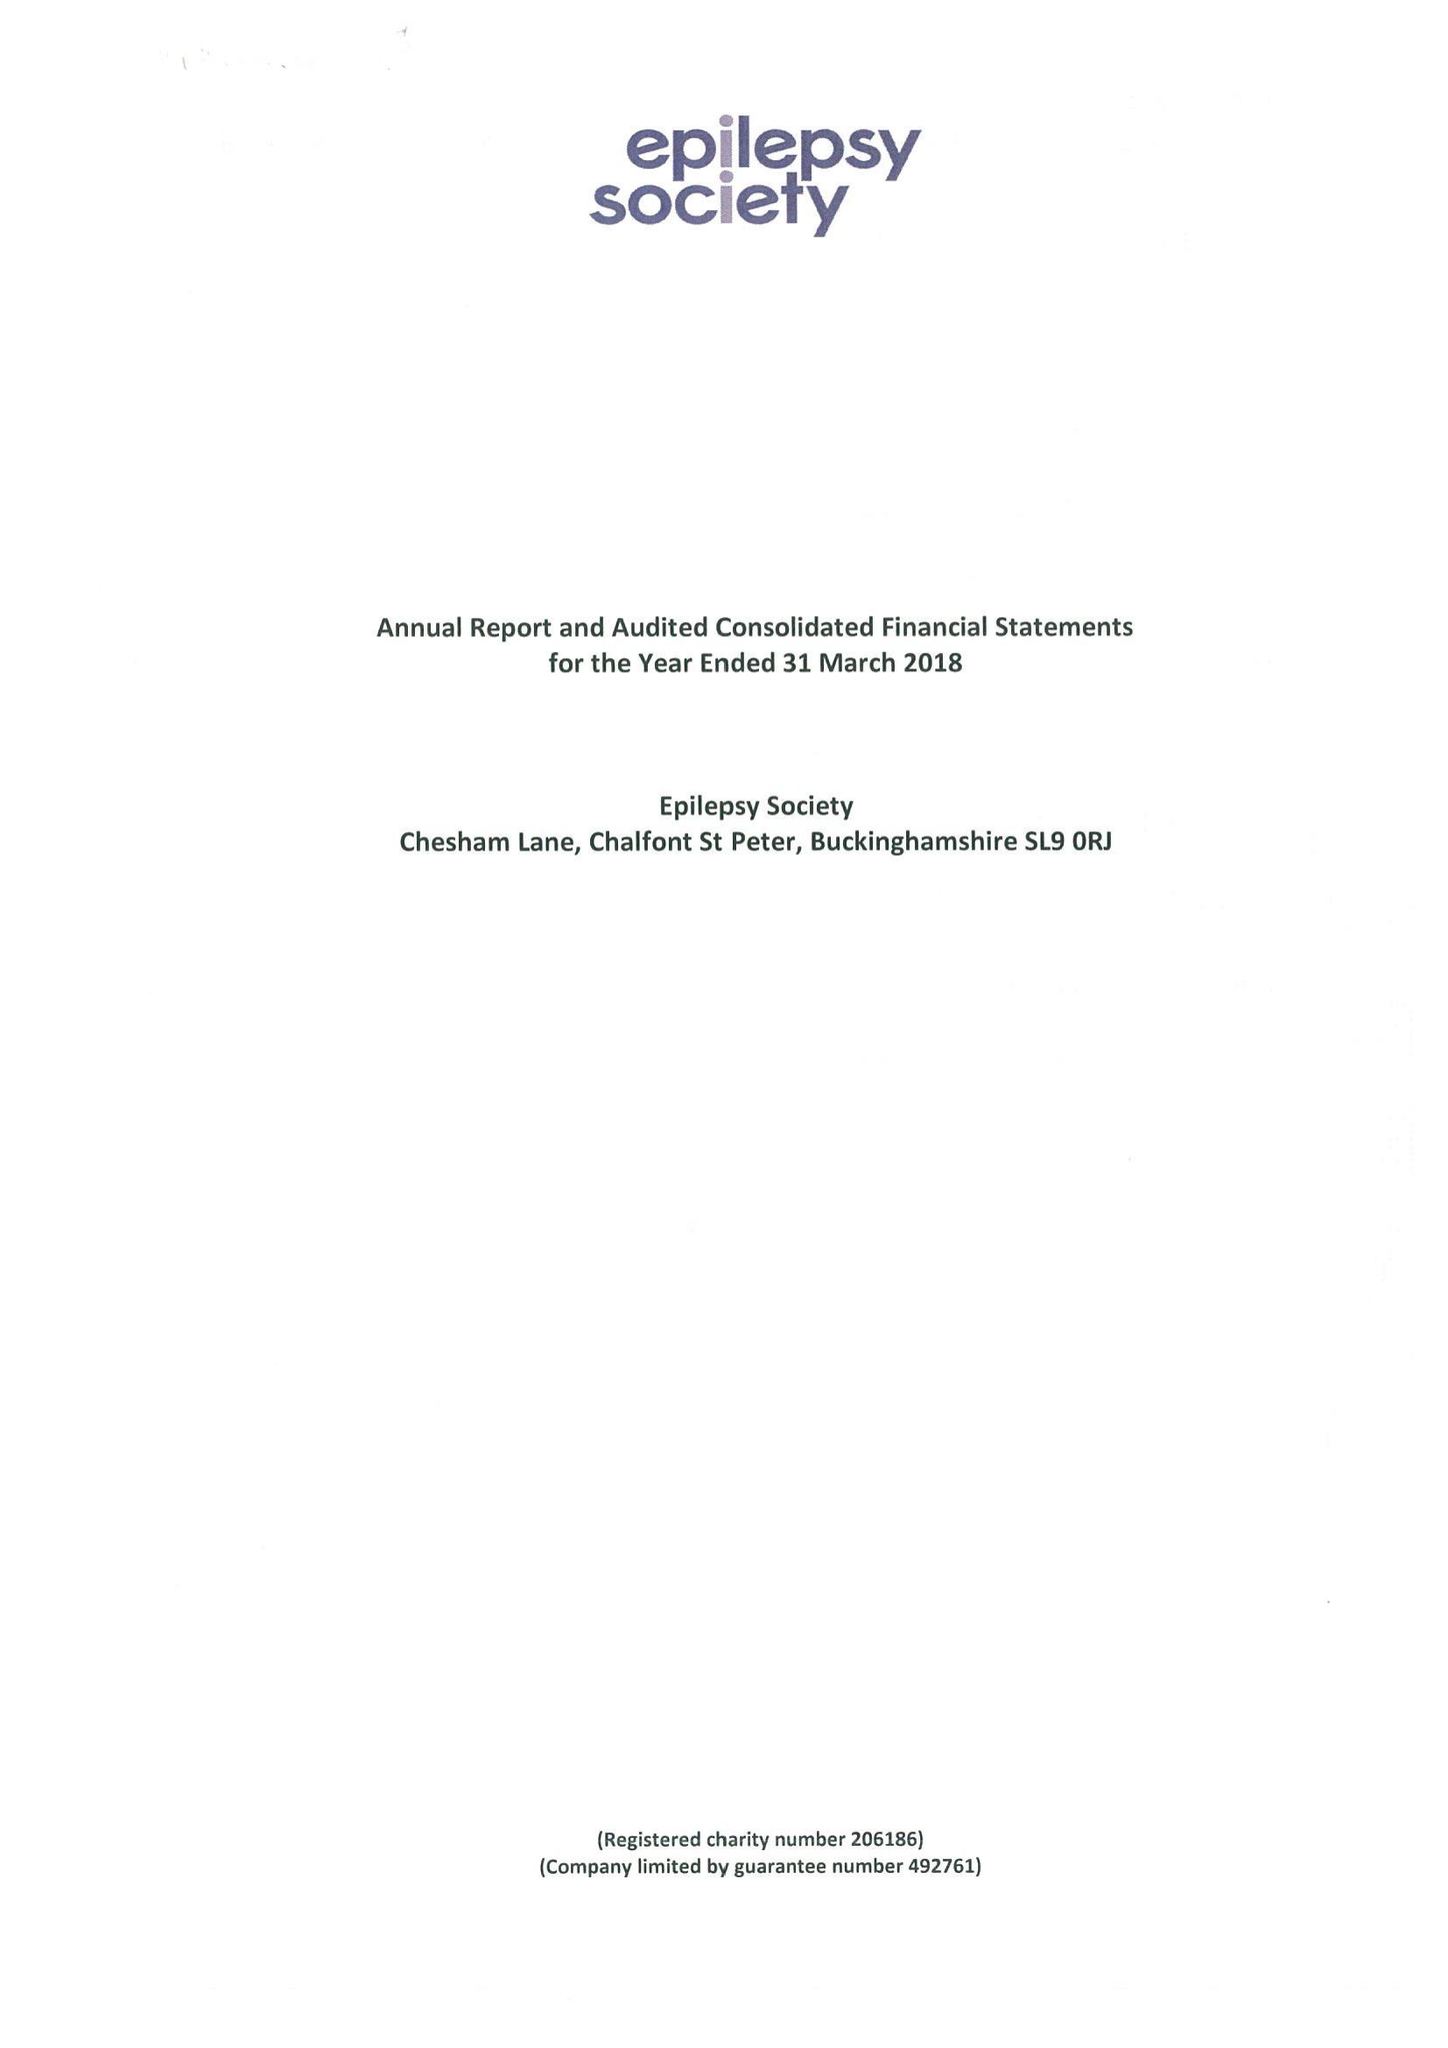What is the value for the charity_name?
Answer the question using a single word or phrase. Epilepsy Society 